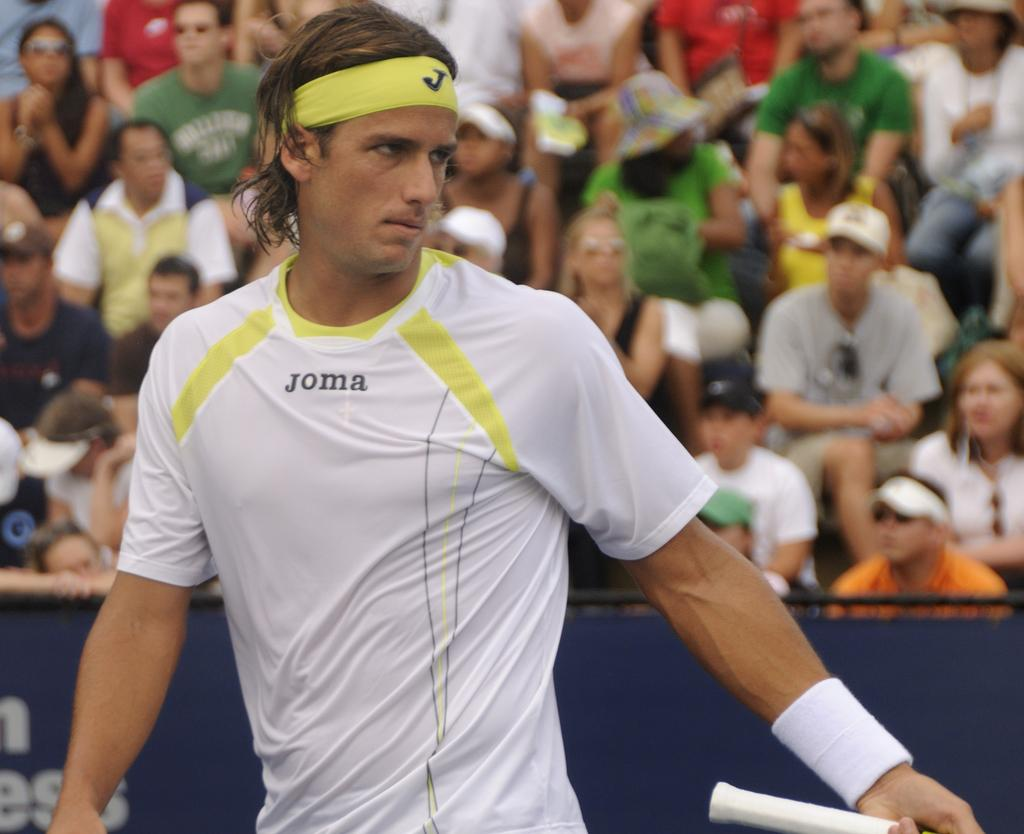What is the main subject of the image? There is a man standing in the image. What is the man wearing on his head? The man is wearing a headband. Can you describe the people in the background of the image? There are people sitting in the background of the image. What type of iron can be seen in the image? There is no iron present in the image. What color is the copper hat worn by the man in the image? There is no copper hat worn by the man in the image; he is wearing a headband. 